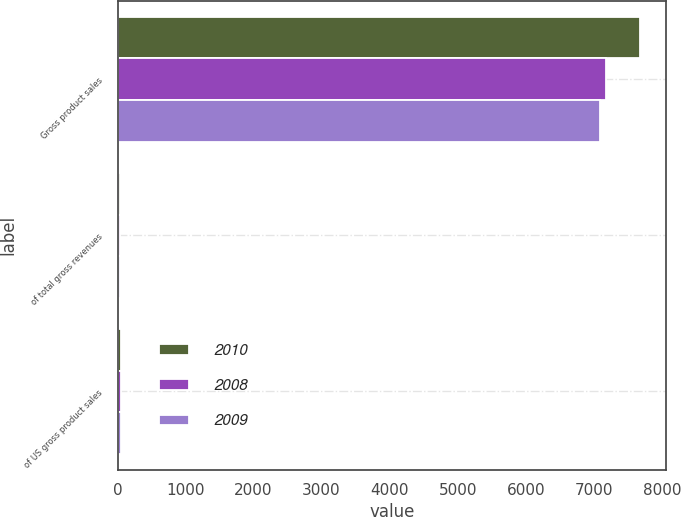<chart> <loc_0><loc_0><loc_500><loc_500><stacked_bar_chart><ecel><fcel>Gross product sales<fcel>of total gross revenues<fcel>of US gross product sales<nl><fcel>2010<fcel>7678<fcel>38<fcel>47<nl><fcel>2008<fcel>7179<fcel>37<fcel>46<nl><fcel>2009<fcel>7099<fcel>37<fcel>46<nl></chart> 